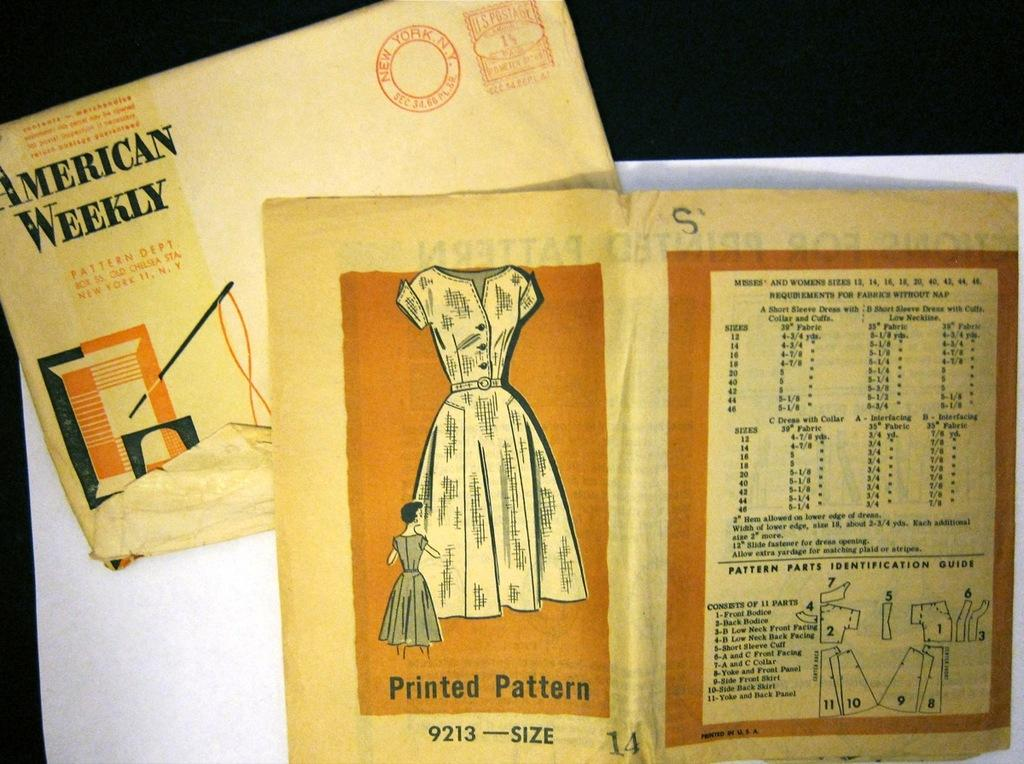What is the person in the image holding? The person is holding a camera. What can be seen in the background of the image? There is a building in the background of the image. What type of shop can be seen in the image? There is no shop present in the image; it features a person holding a camera with a building in the background. 